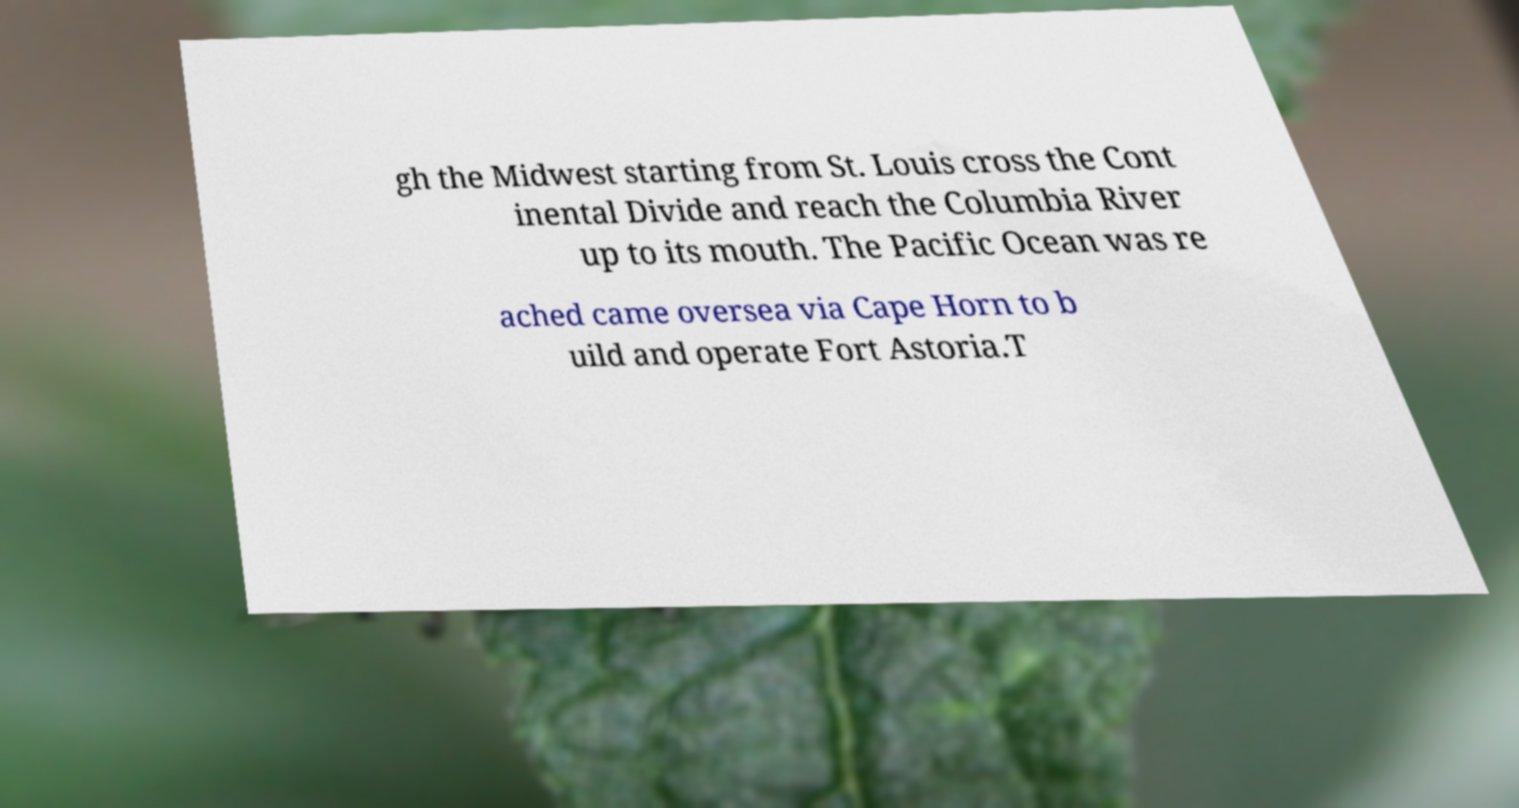What messages or text are displayed in this image? I need them in a readable, typed format. gh the Midwest starting from St. Louis cross the Cont inental Divide and reach the Columbia River up to its mouth. The Pacific Ocean was re ached came oversea via Cape Horn to b uild and operate Fort Astoria.T 